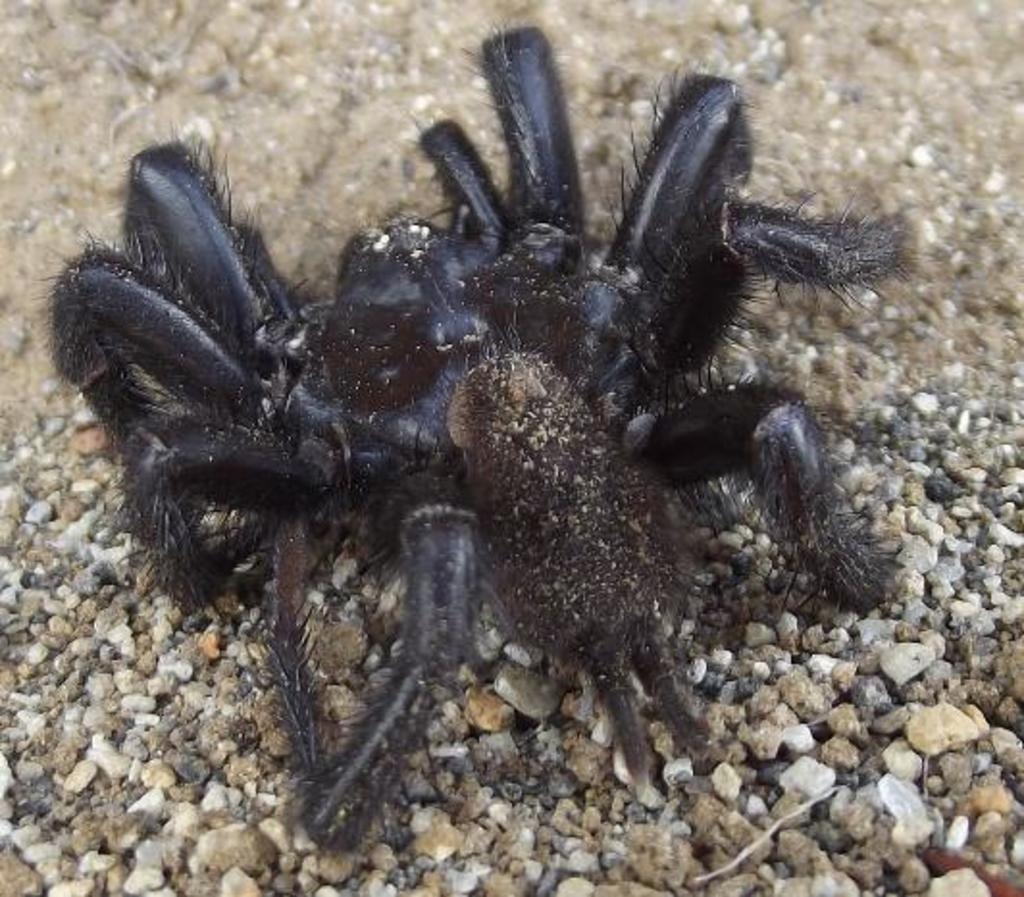What type of creature can be seen in the image? There is an insect in the image. What is the color of the insect? The insect is black in color. What other objects are present in the image besides the insect? There are stones in the image. What colors are the stones? The stones are in white and brown colors. What type of cloth is being used to cover the insect's stomach in the image? There is no cloth or reference to the insect's stomach in the image. 